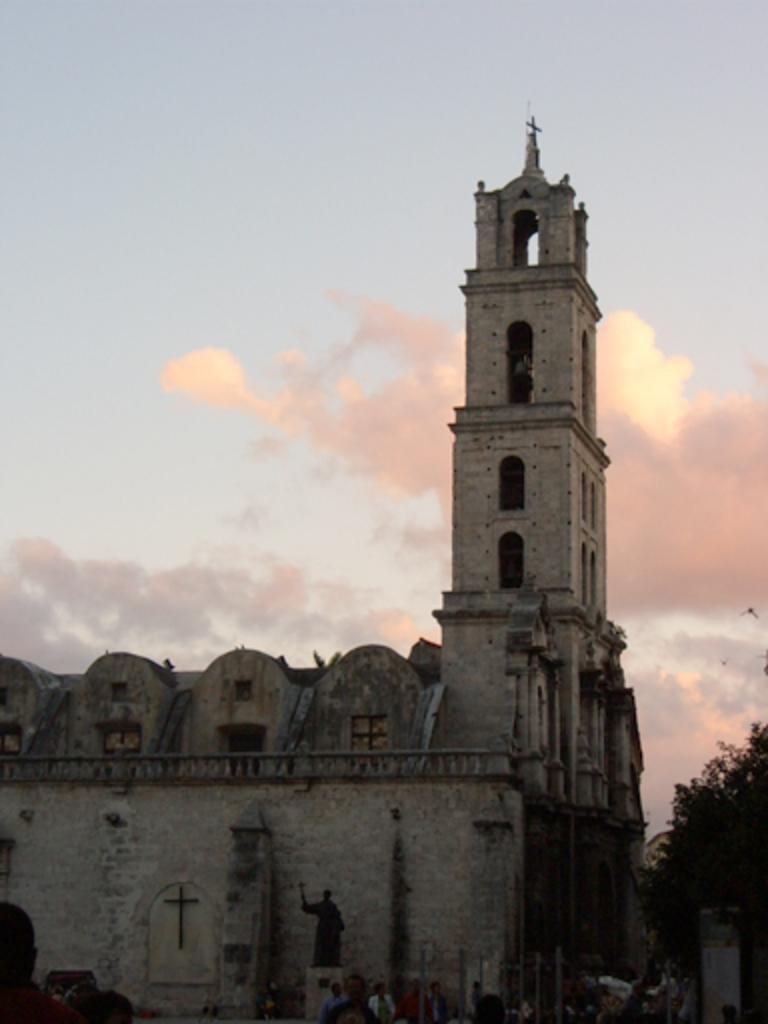What type of structures can be seen in the image? There are buildings in the image. What is the statue in the image depicting? The statue in the image is a specific subject or figure. Can you describe the people in the image? There are people in the image, but their specific actions or characteristics are not mentioned in the facts. What type of vegetation is present in the image? There is a tree in the image. What is visible in the background of the image? The sky is visible in the image, and clouds are present in the sky. What type of advice can be seen written on the cord in the image? There is no cord present in the image, so it is not possible to answer that question. 